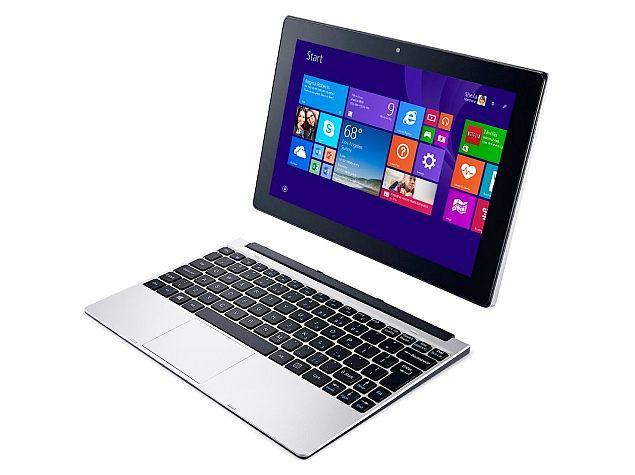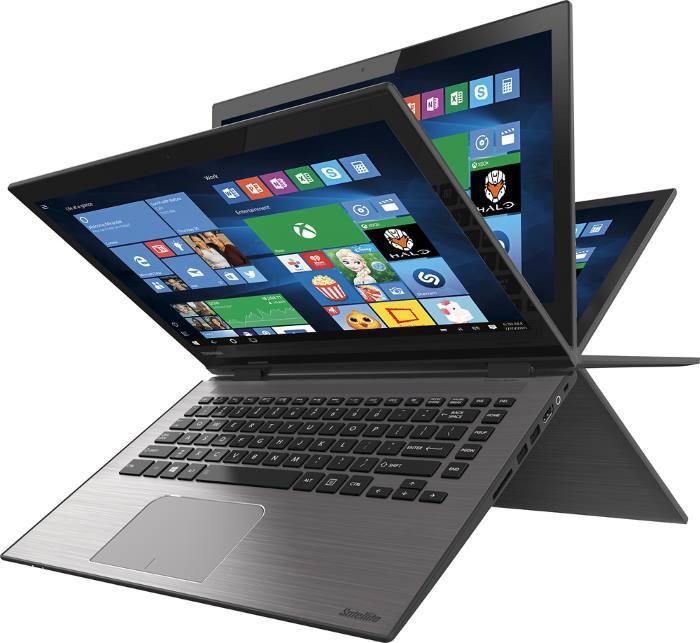The first image is the image on the left, the second image is the image on the right. Assess this claim about the two images: "The left image shows a keyboard base separated from the screen, and the right image shows a device with multiple fanned out screens on top of an inverted V base.". Correct or not? Answer yes or no. Yes. The first image is the image on the left, the second image is the image on the right. For the images shown, is this caption "The laptop in the image on the right is shown opening is several positions." true? Answer yes or no. Yes. 